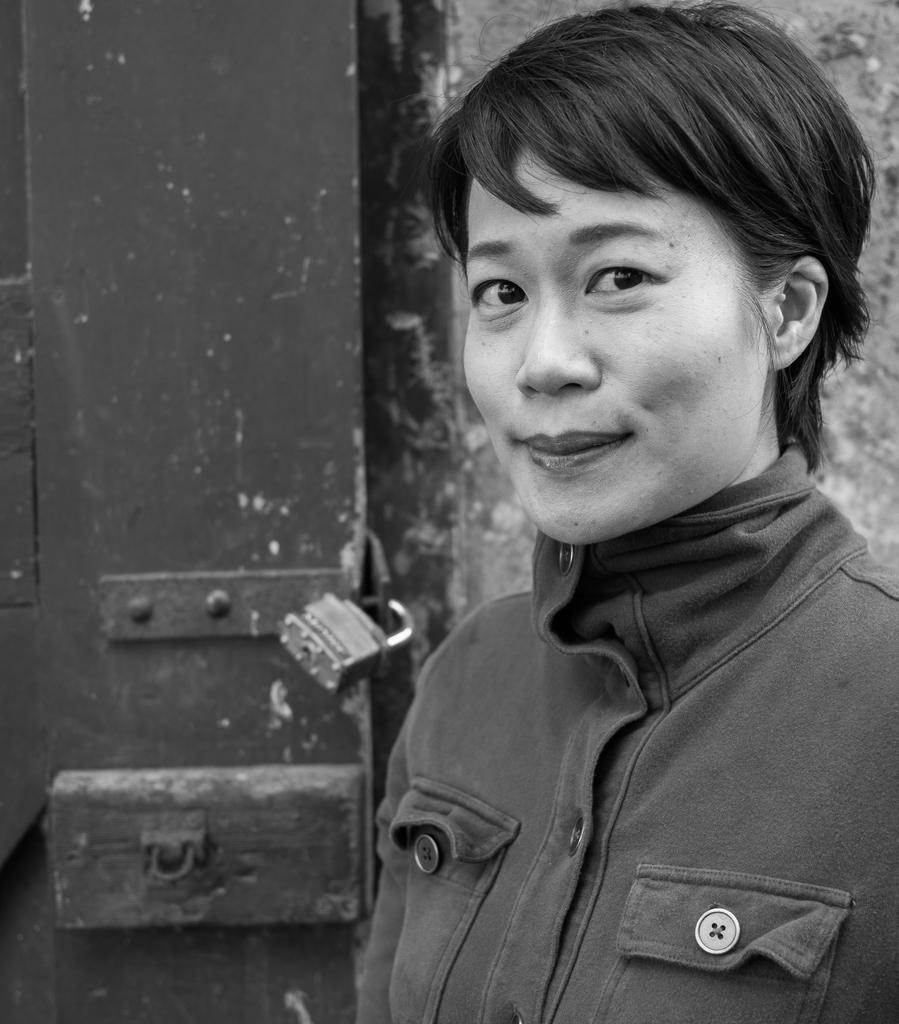Who is the main subject in the image? There is a lady in the image. What is the lady doing in the image? The lady is standing. What is the lady wearing in the image? The lady is wearing a jacket. What can be seen in the background of the image? There is a door in the image, and a lock is present on the door. What advice does the lady give to the person on the trip in the image? There is no trip or person mentioned in the image; it only features a lady standing and wearing a jacket, with a door and a lock in the background. 